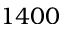Convert formula to latex. <formula><loc_0><loc_0><loc_500><loc_500>1 4 0 0</formula> 